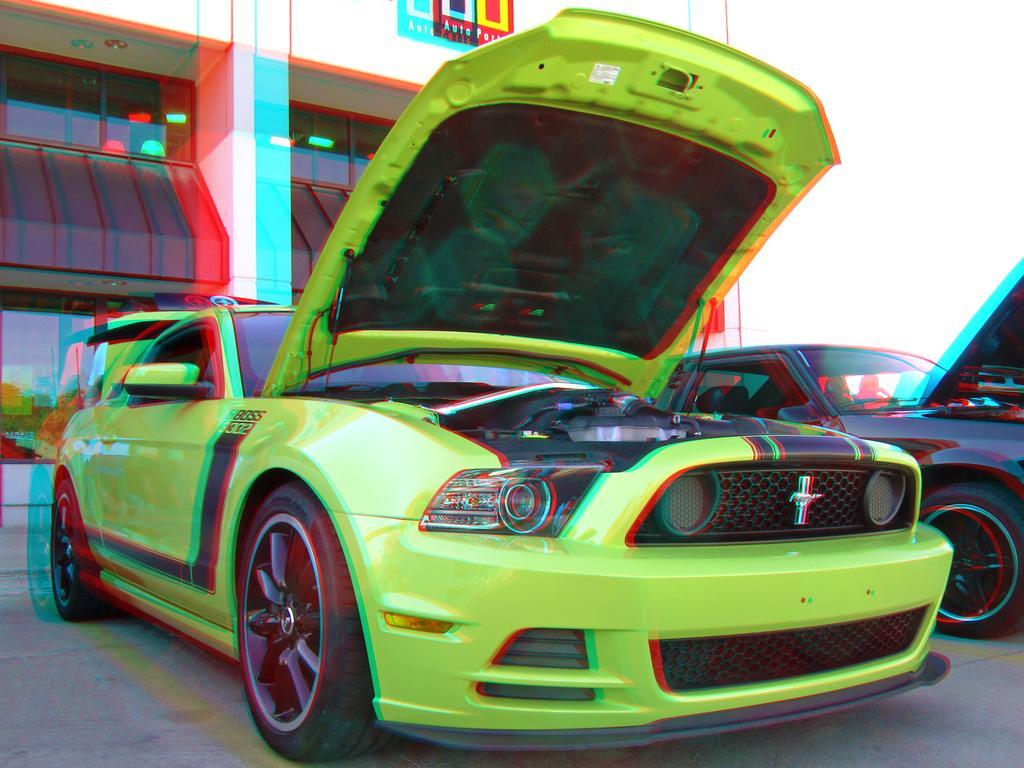Describe this image in one or two sentences. In this image we can see two cars on the road and a building behind the cars. 